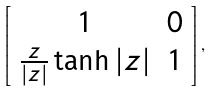Convert formula to latex. <formula><loc_0><loc_0><loc_500><loc_500>\left [ \begin{array} [ c ] { c c } 1 & 0 \\ \frac { z } { | z | } \tanh | z | & 1 \end{array} \right ] ,</formula> 